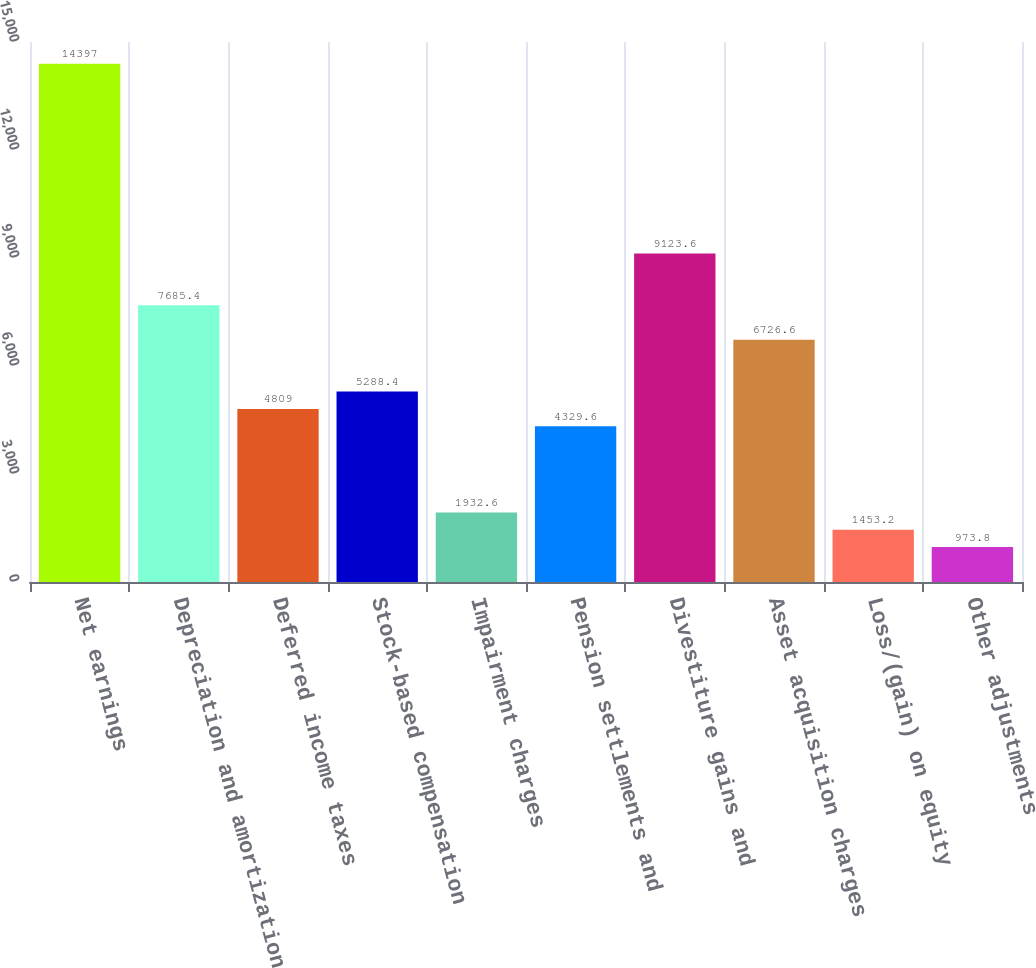Convert chart to OTSL. <chart><loc_0><loc_0><loc_500><loc_500><bar_chart><fcel>Net earnings<fcel>Depreciation and amortization<fcel>Deferred income taxes<fcel>Stock-based compensation<fcel>Impairment charges<fcel>Pension settlements and<fcel>Divestiture gains and<fcel>Asset acquisition charges<fcel>Loss/(gain) on equity<fcel>Other adjustments<nl><fcel>14397<fcel>7685.4<fcel>4809<fcel>5288.4<fcel>1932.6<fcel>4329.6<fcel>9123.6<fcel>6726.6<fcel>1453.2<fcel>973.8<nl></chart> 